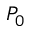<formula> <loc_0><loc_0><loc_500><loc_500>P _ { 0 }</formula> 